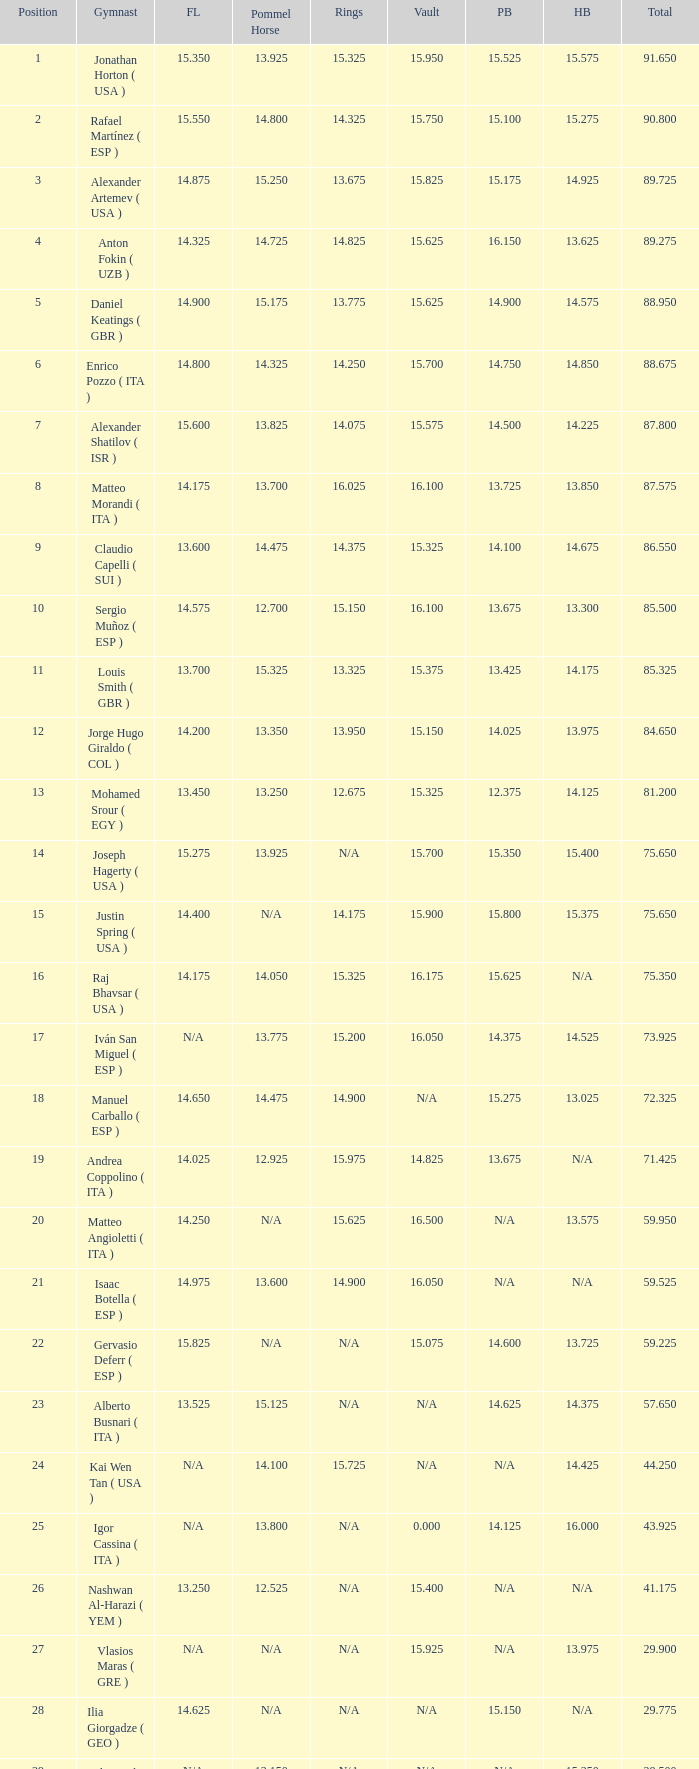If the floor number is 14.200, what is the number for the parallel bars? 14.025. 